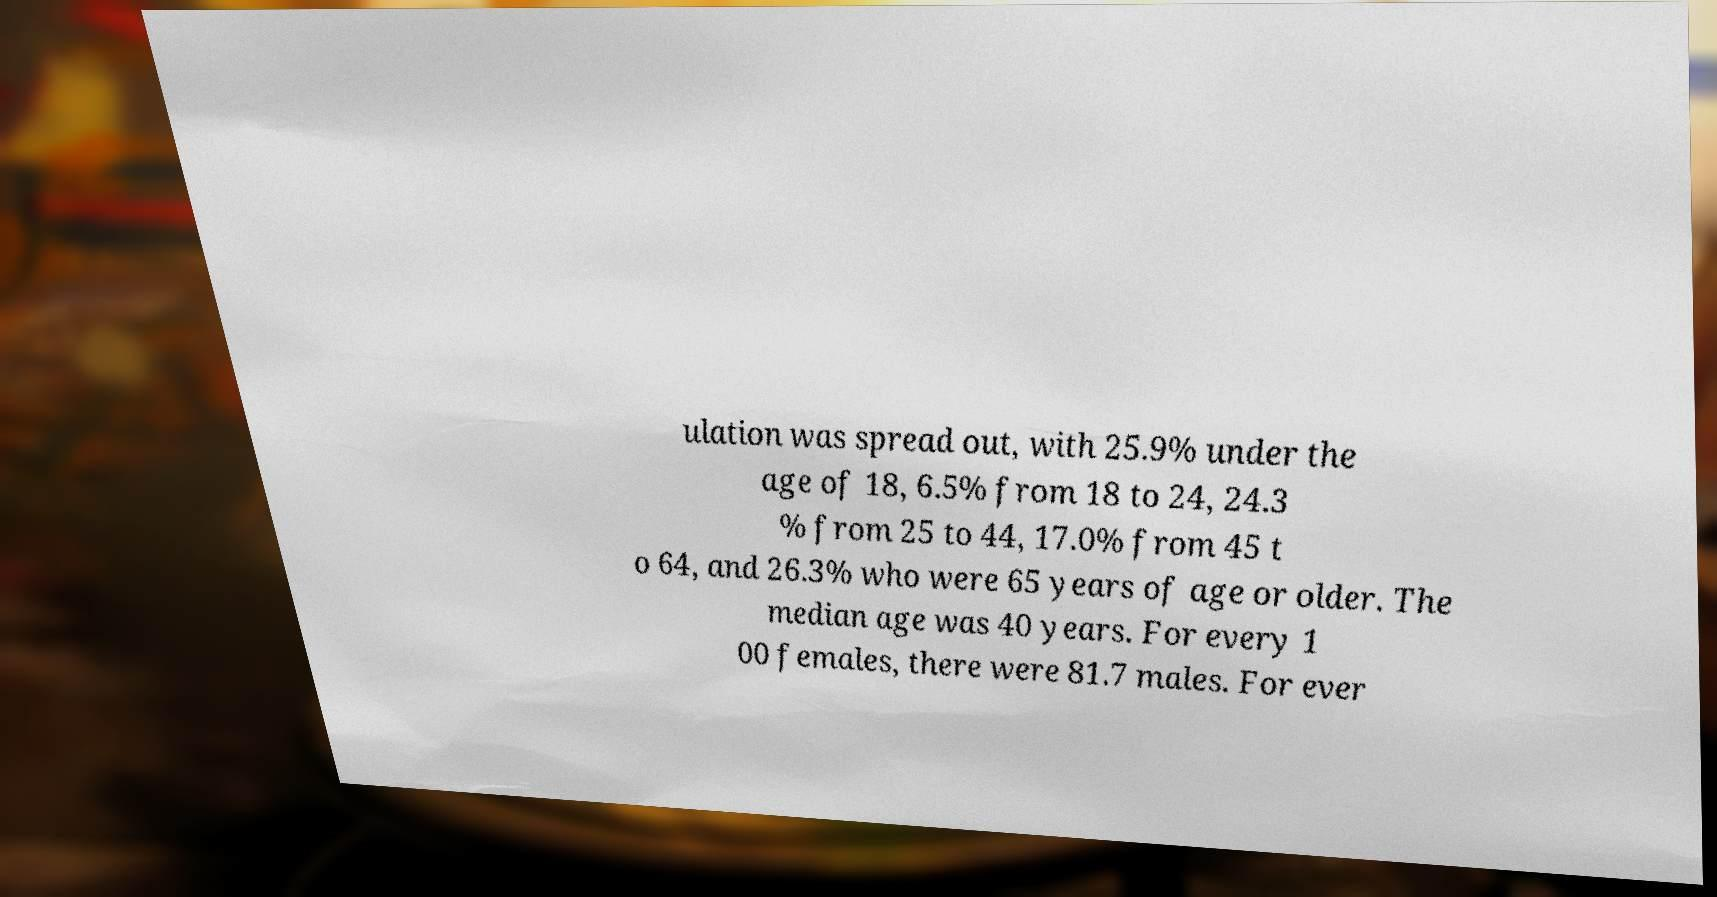Can you read and provide the text displayed in the image?This photo seems to have some interesting text. Can you extract and type it out for me? ulation was spread out, with 25.9% under the age of 18, 6.5% from 18 to 24, 24.3 % from 25 to 44, 17.0% from 45 t o 64, and 26.3% who were 65 years of age or older. The median age was 40 years. For every 1 00 females, there were 81.7 males. For ever 